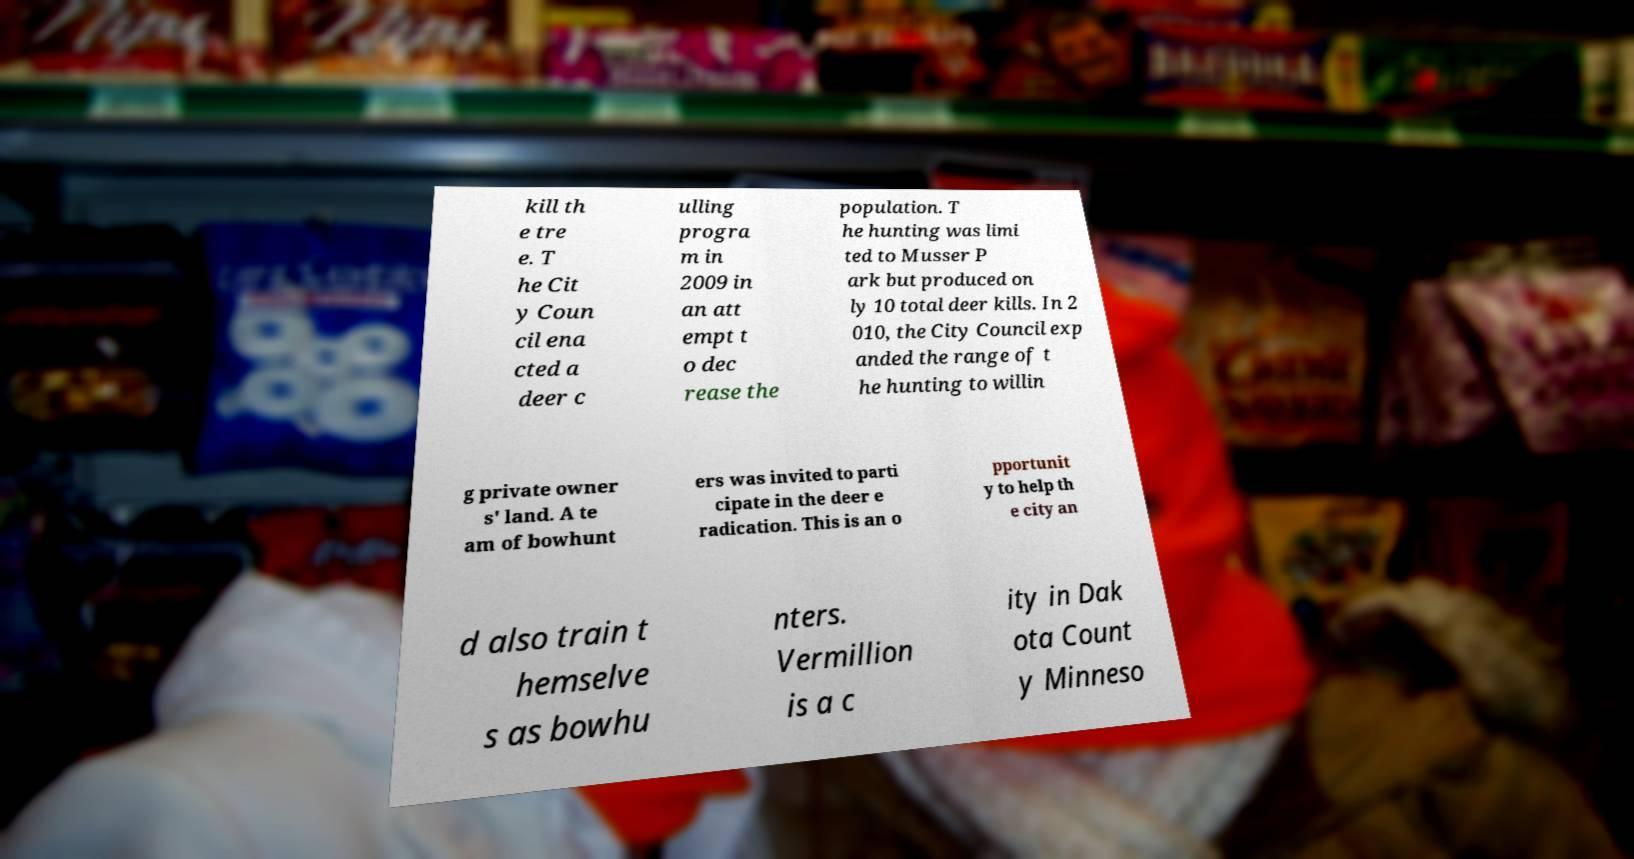There's text embedded in this image that I need extracted. Can you transcribe it verbatim? kill th e tre e. T he Cit y Coun cil ena cted a deer c ulling progra m in 2009 in an att empt t o dec rease the population. T he hunting was limi ted to Musser P ark but produced on ly 10 total deer kills. In 2 010, the City Council exp anded the range of t he hunting to willin g private owner s' land. A te am of bowhunt ers was invited to parti cipate in the deer e radication. This is an o pportunit y to help th e city an d also train t hemselve s as bowhu nters. Vermillion is a c ity in Dak ota Count y Minneso 